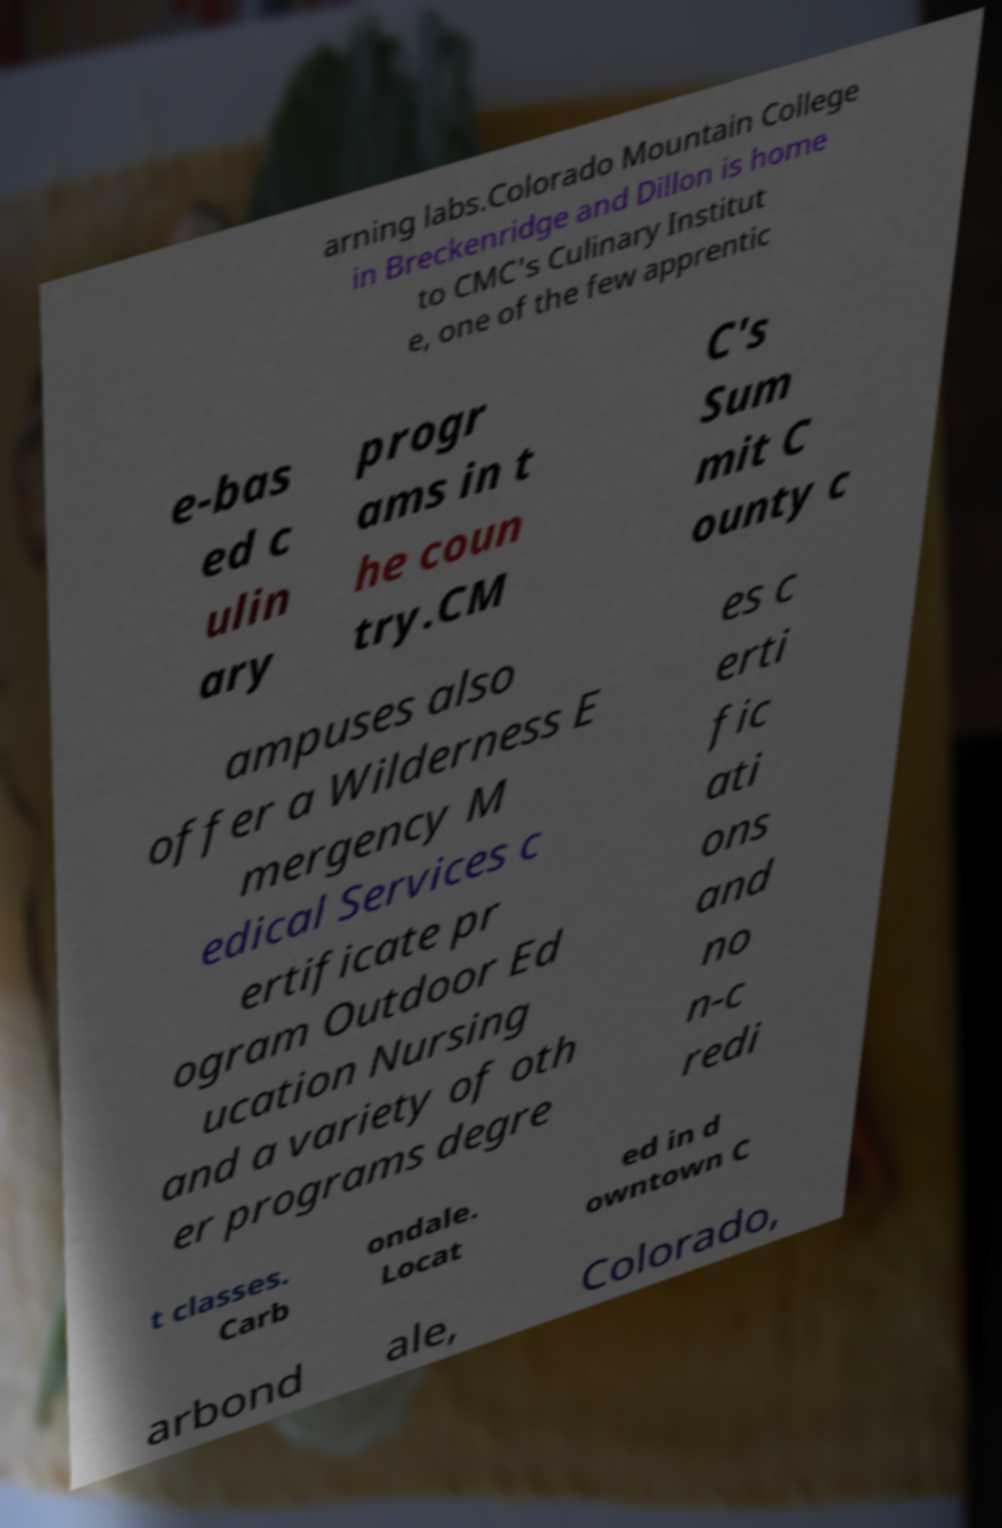There's text embedded in this image that I need extracted. Can you transcribe it verbatim? arning labs.Colorado Mountain College in Breckenridge and Dillon is home to CMC's Culinary Institut e, one of the few apprentic e-bas ed c ulin ary progr ams in t he coun try.CM C's Sum mit C ounty c ampuses also offer a Wilderness E mergency M edical Services c ertificate pr ogram Outdoor Ed ucation Nursing and a variety of oth er programs degre es c erti fic ati ons and no n-c redi t classes. Carb ondale. Locat ed in d owntown C arbond ale, Colorado, 